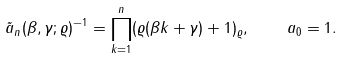Convert formula to latex. <formula><loc_0><loc_0><loc_500><loc_500>\tilde { a } _ { n } ( \beta , \gamma ; \varrho ) ^ { - 1 } = \prod _ { k = 1 } ^ { n } ( \varrho ( \beta k + \gamma ) + 1 ) _ { \varrho } , \quad a _ { 0 } = 1 .</formula> 